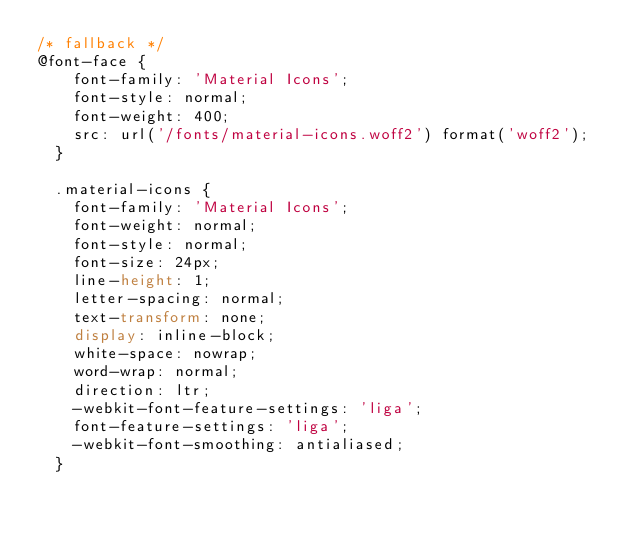<code> <loc_0><loc_0><loc_500><loc_500><_CSS_>/* fallback */
@font-face {
    font-family: 'Material Icons';
    font-style: normal;
    font-weight: 400;
    src: url('/fonts/material-icons.woff2') format('woff2');
  }

  .material-icons {
    font-family: 'Material Icons';
    font-weight: normal;
    font-style: normal;
    font-size: 24px;
    line-height: 1;
    letter-spacing: normal;
    text-transform: none;
    display: inline-block;
    white-space: nowrap;
    word-wrap: normal;
    direction: ltr;
    -webkit-font-feature-settings: 'liga';
    font-feature-settings: 'liga';
    -webkit-font-smoothing: antialiased;
  }
</code> 